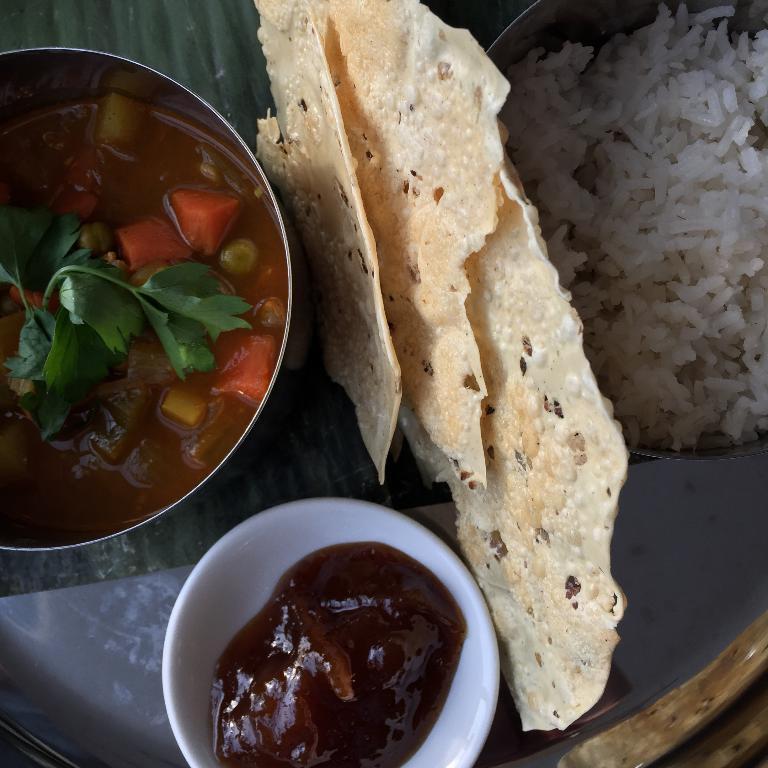How would you summarize this image in a sentence or two? In this image I can see three bowls placed on a glass table holding different food items and I can see a different food item placed in between the bowls. 